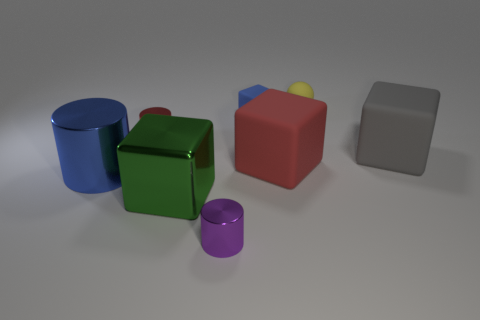What might be the purpose of arranging these objects together like this? These objects may be arranged together for educational purposes, such as teaching children or students about geometry, volumes, surface areas, and spatial relationships. They could also be pieces used in a 3D rendering or graphic design project to showcase texture, lighting, and reflections. 